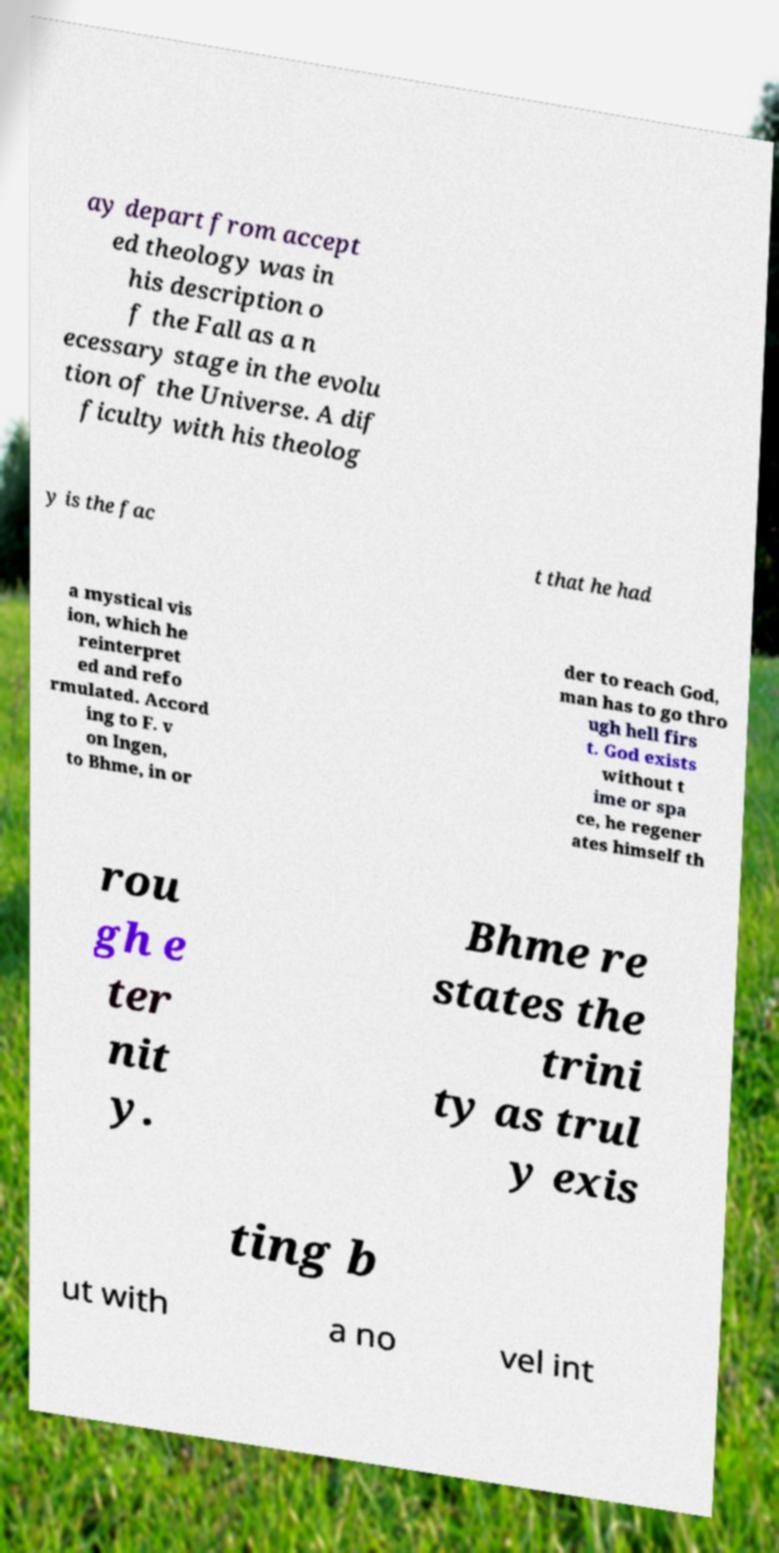I need the written content from this picture converted into text. Can you do that? ay depart from accept ed theology was in his description o f the Fall as a n ecessary stage in the evolu tion of the Universe. A dif ficulty with his theolog y is the fac t that he had a mystical vis ion, which he reinterpret ed and refo rmulated. Accord ing to F. v on Ingen, to Bhme, in or der to reach God, man has to go thro ugh hell firs t. God exists without t ime or spa ce, he regener ates himself th rou gh e ter nit y. Bhme re states the trini ty as trul y exis ting b ut with a no vel int 